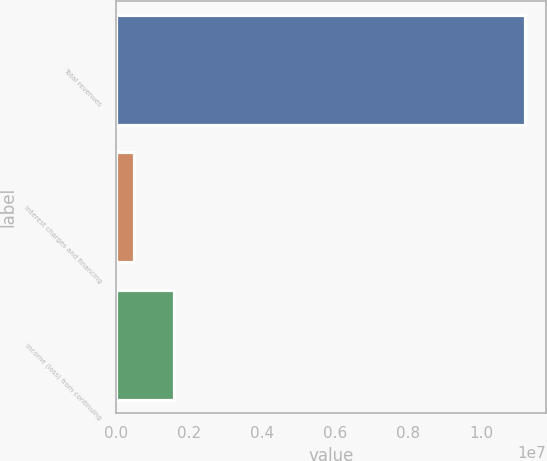Convert chart to OTSL. <chart><loc_0><loc_0><loc_500><loc_500><bar_chart><fcel>Total revenues<fcel>Interest charges and financing<fcel>Income (loss) from continuing<nl><fcel>1.12032e+07<fcel>513881<fcel>1.58281e+06<nl></chart> 